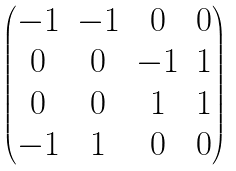Convert formula to latex. <formula><loc_0><loc_0><loc_500><loc_500>\begin{pmatrix} - 1 & - 1 & 0 & 0 \\ 0 & 0 & - 1 & 1 \\ 0 & 0 & 1 & 1 \\ - 1 & 1 & 0 & 0 \end{pmatrix}</formula> 